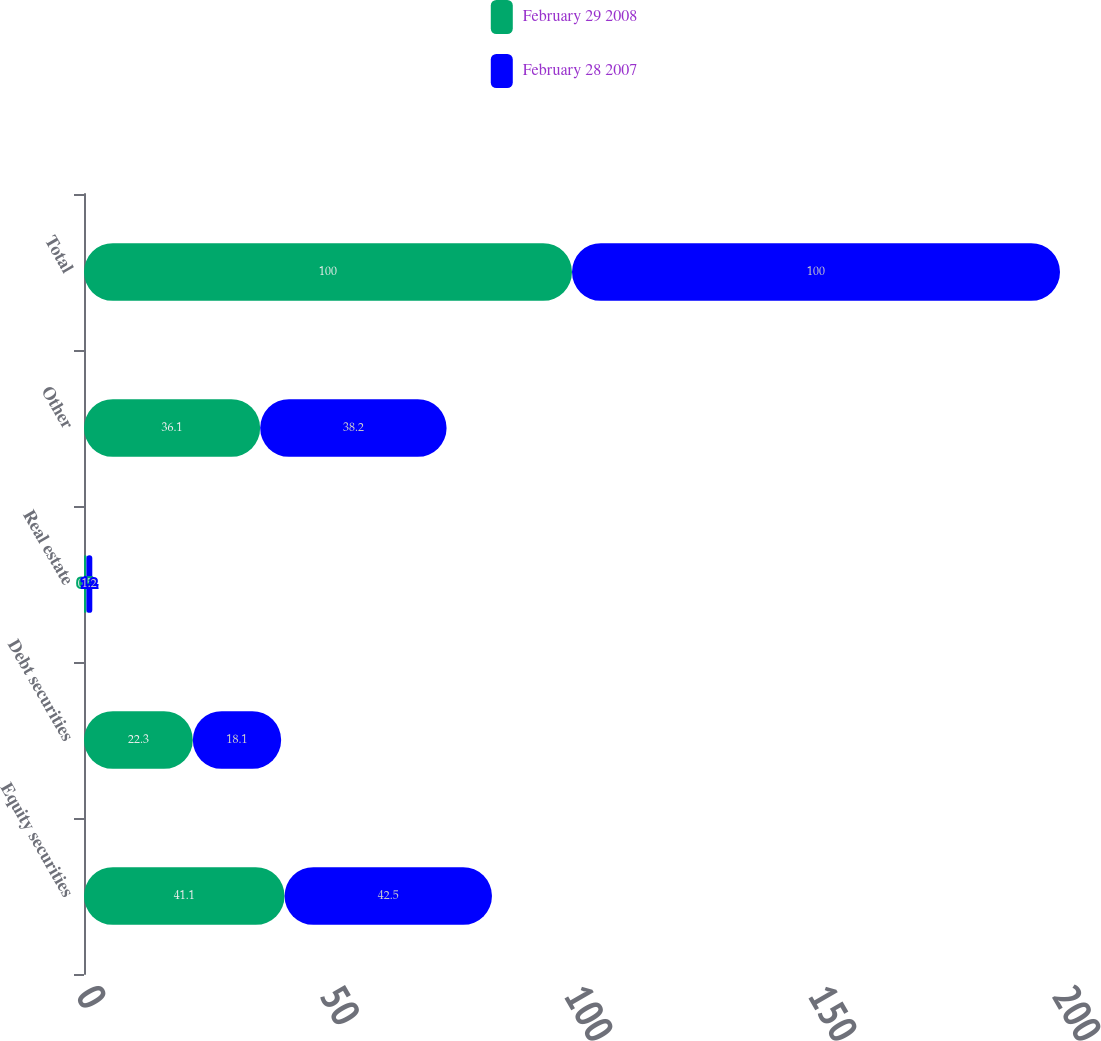Convert chart to OTSL. <chart><loc_0><loc_0><loc_500><loc_500><stacked_bar_chart><ecel><fcel>Equity securities<fcel>Debt securities<fcel>Real estate<fcel>Other<fcel>Total<nl><fcel>February 29 2008<fcel>41.1<fcel>22.3<fcel>0.5<fcel>36.1<fcel>100<nl><fcel>February 28 2007<fcel>42.5<fcel>18.1<fcel>1.2<fcel>38.2<fcel>100<nl></chart> 